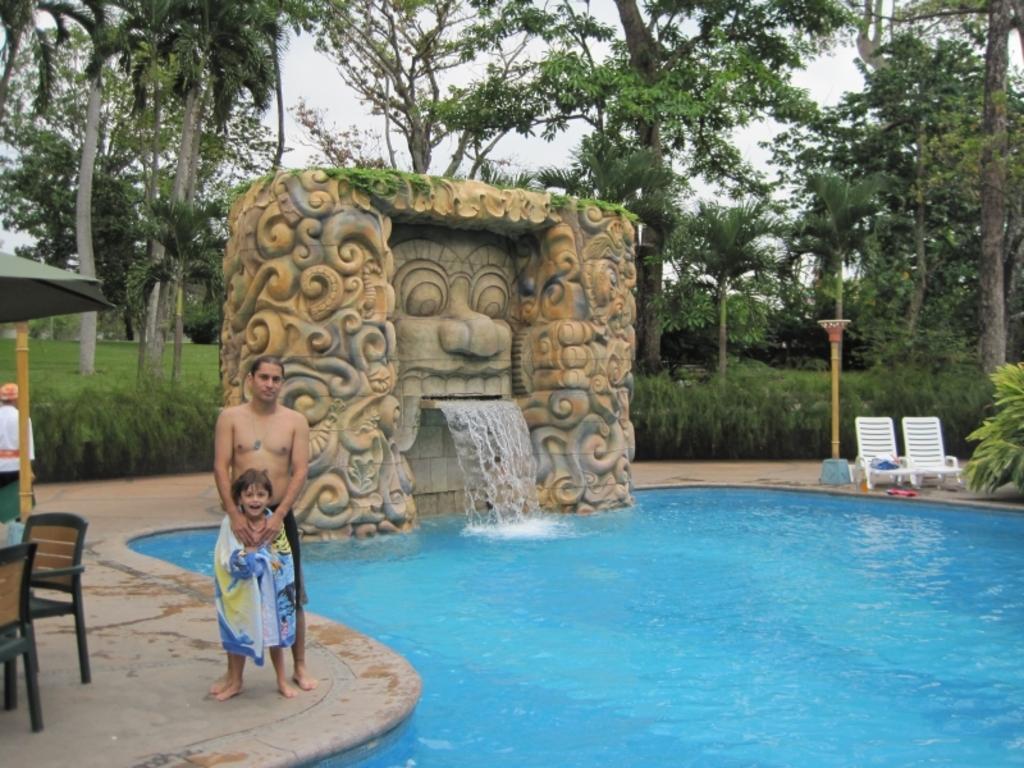Can you describe this image briefly? In the image there is a fountain with sculpture. In front of that there is a swimming pool. In the image there are two persons standing on the floor. There are trees, chairs and tents.  